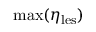Convert formula to latex. <formula><loc_0><loc_0><loc_500><loc_500>\max ( \eta _ { l e s } )</formula> 